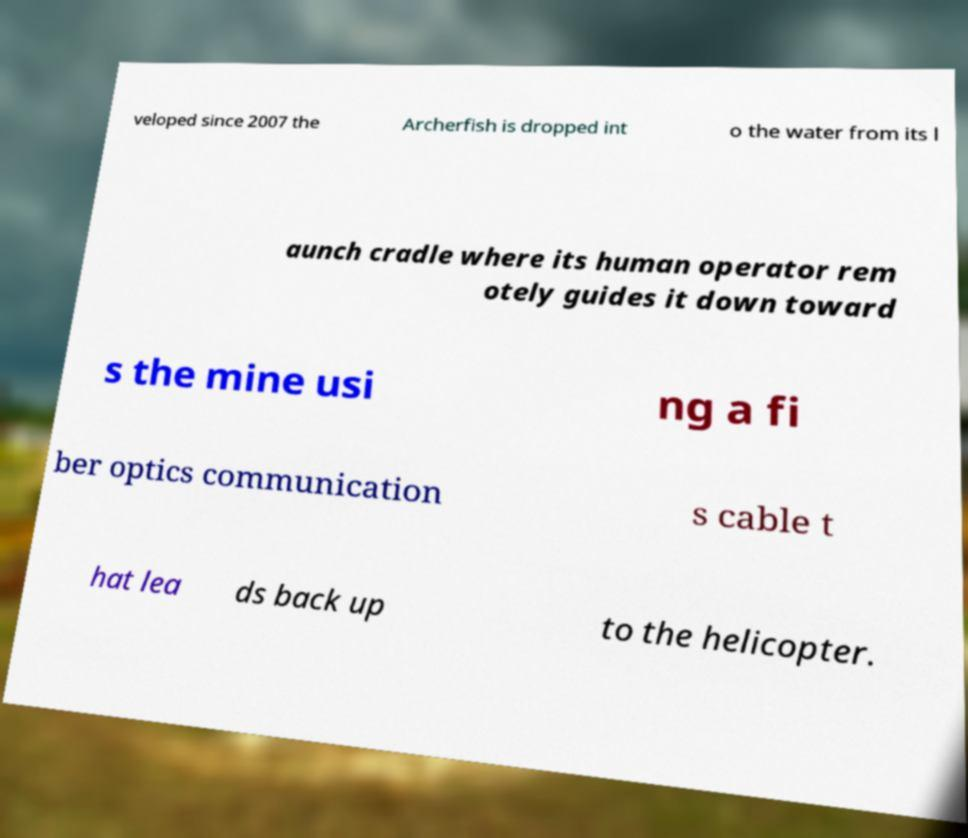What messages or text are displayed in this image? I need them in a readable, typed format. veloped since 2007 the Archerfish is dropped int o the water from its l aunch cradle where its human operator rem otely guides it down toward s the mine usi ng a fi ber optics communication s cable t hat lea ds back up to the helicopter. 